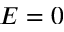<formula> <loc_0><loc_0><loc_500><loc_500>E = 0</formula> 